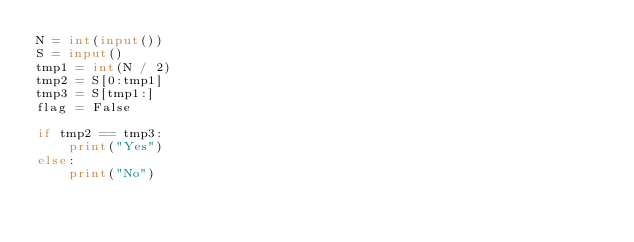<code> <loc_0><loc_0><loc_500><loc_500><_Python_>N = int(input())
S = input()
tmp1 = int(N / 2)
tmp2 = S[0:tmp1]
tmp3 = S[tmp1:]
flag = False

if tmp2 == tmp3:
    print("Yes")
else:
    print("No")
</code> 